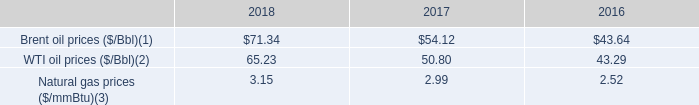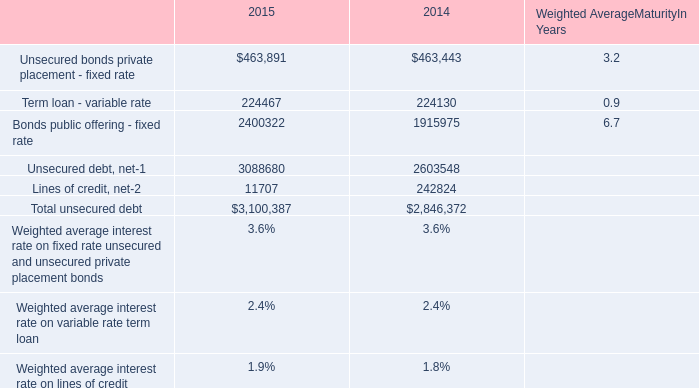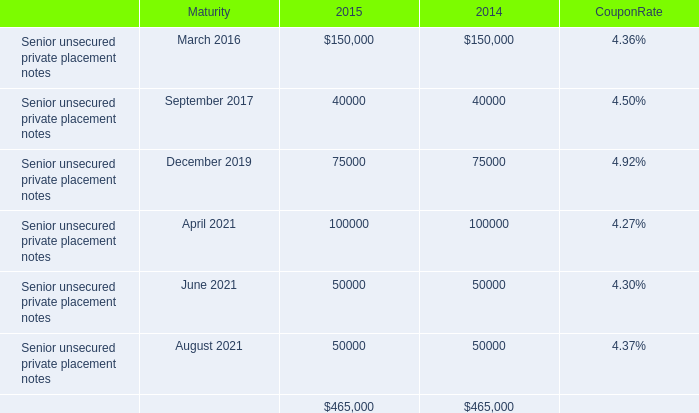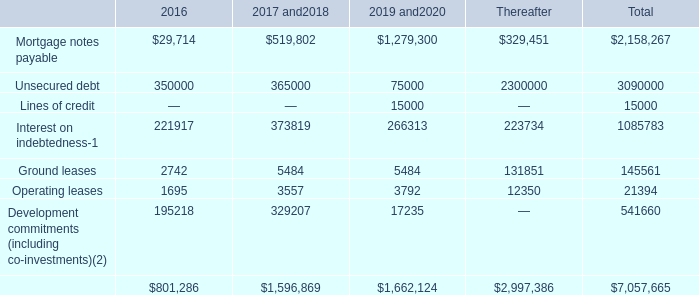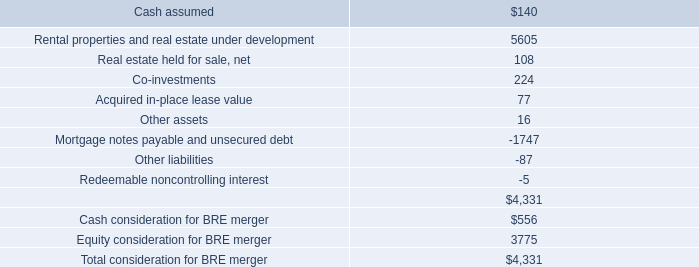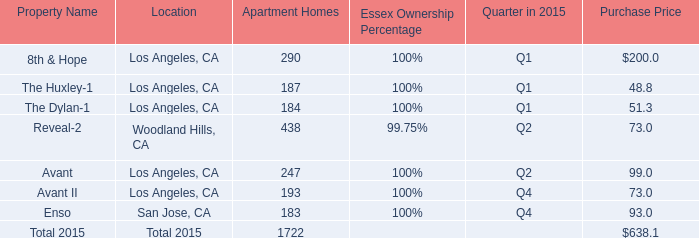What is the average amount of Unsecured debt, net of 2014, and Ground leases of 2017 and2018 ? 
Computations: ((2603548.0 + 5484.0) / 2)
Answer: 1304516.0. 